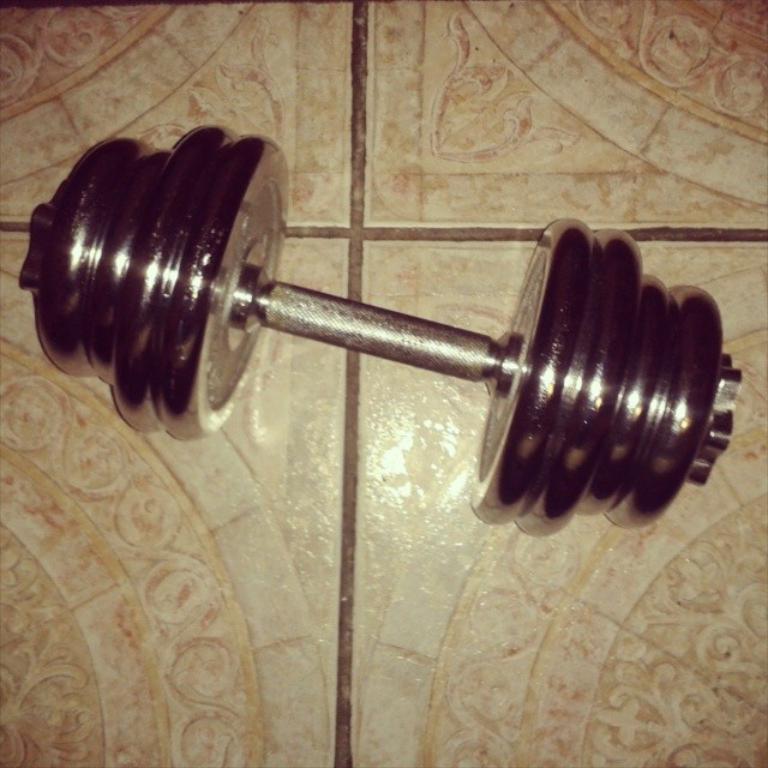Can you describe this image briefly? In this picture there is a barbell in the center of the image, on a floor. 